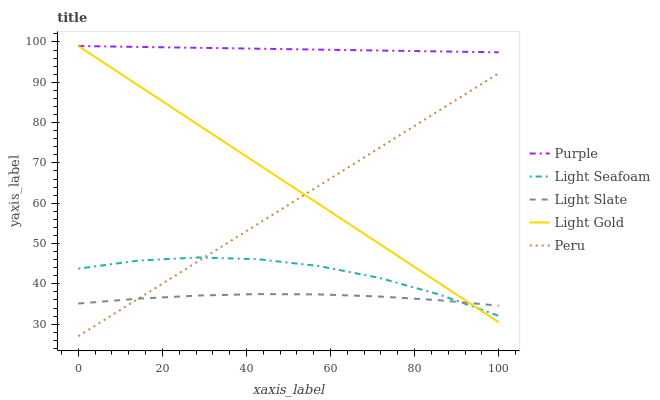Does Light Slate have the minimum area under the curve?
Answer yes or no. Yes. Does Purple have the maximum area under the curve?
Answer yes or no. Yes. Does Light Seafoam have the minimum area under the curve?
Answer yes or no. No. Does Light Seafoam have the maximum area under the curve?
Answer yes or no. No. Is Peru the smoothest?
Answer yes or no. Yes. Is Light Seafoam the roughest?
Answer yes or no. Yes. Is Light Slate the smoothest?
Answer yes or no. No. Is Light Slate the roughest?
Answer yes or no. No. Does Peru have the lowest value?
Answer yes or no. Yes. Does Light Slate have the lowest value?
Answer yes or no. No. Does Light Gold have the highest value?
Answer yes or no. Yes. Does Light Seafoam have the highest value?
Answer yes or no. No. Is Light Slate less than Purple?
Answer yes or no. Yes. Is Purple greater than Peru?
Answer yes or no. Yes. Does Light Slate intersect Light Seafoam?
Answer yes or no. Yes. Is Light Slate less than Light Seafoam?
Answer yes or no. No. Is Light Slate greater than Light Seafoam?
Answer yes or no. No. Does Light Slate intersect Purple?
Answer yes or no. No. 